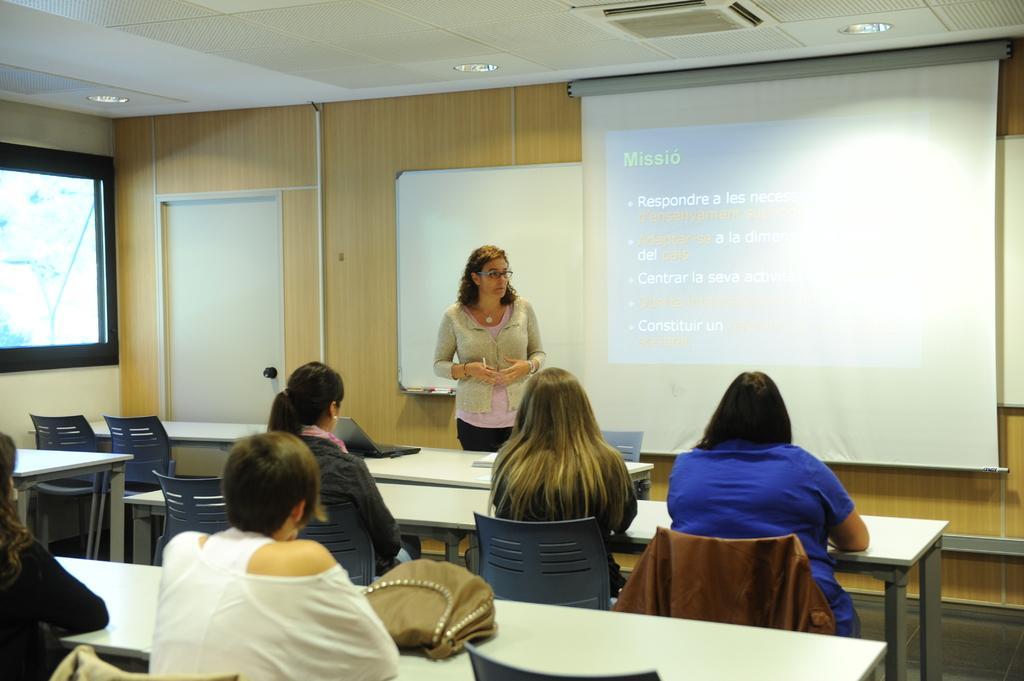Can you describe this image briefly? In this image I can see group of people sitting in-front of the table. On the table there is a bag and laptop. In front of them there is a person standing. In the background there is a screen. 